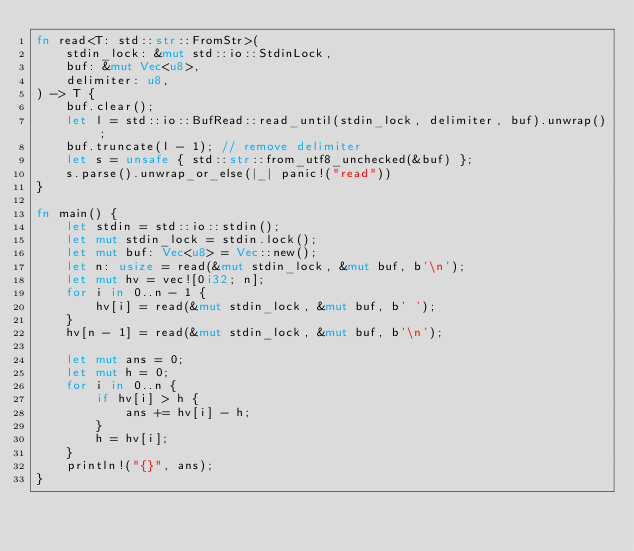<code> <loc_0><loc_0><loc_500><loc_500><_Rust_>fn read<T: std::str::FromStr>(
    stdin_lock: &mut std::io::StdinLock,
    buf: &mut Vec<u8>,
    delimiter: u8,
) -> T {
    buf.clear();
    let l = std::io::BufRead::read_until(stdin_lock, delimiter, buf).unwrap();
    buf.truncate(l - 1); // remove delimiter
    let s = unsafe { std::str::from_utf8_unchecked(&buf) };
    s.parse().unwrap_or_else(|_| panic!("read"))
}

fn main() {
    let stdin = std::io::stdin();
    let mut stdin_lock = stdin.lock();
    let mut buf: Vec<u8> = Vec::new();
    let n: usize = read(&mut stdin_lock, &mut buf, b'\n');
    let mut hv = vec![0i32; n];
    for i in 0..n - 1 {
        hv[i] = read(&mut stdin_lock, &mut buf, b' ');
    }
    hv[n - 1] = read(&mut stdin_lock, &mut buf, b'\n');

    let mut ans = 0;
    let mut h = 0;
    for i in 0..n {
        if hv[i] > h {
            ans += hv[i] - h;
        }
        h = hv[i];
    }
    println!("{}", ans);
}
</code> 